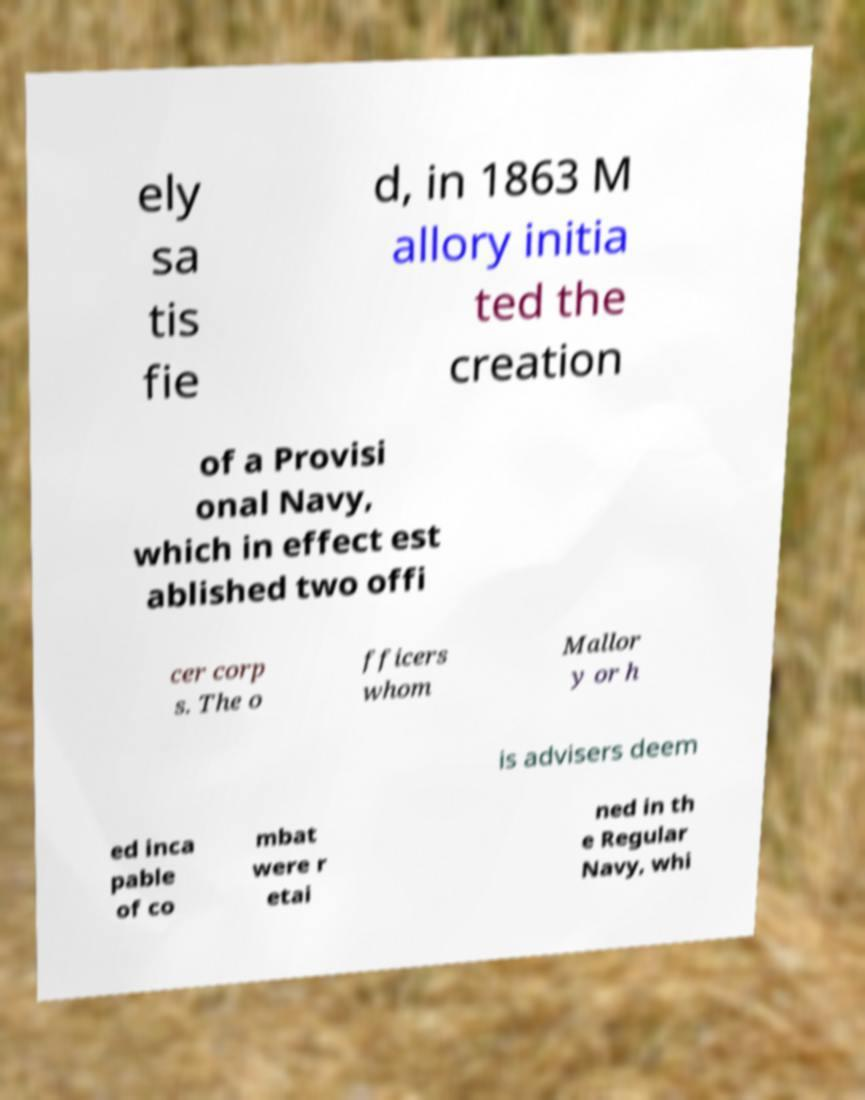Could you assist in decoding the text presented in this image and type it out clearly? ely sa tis fie d, in 1863 M allory initia ted the creation of a Provisi onal Navy, which in effect est ablished two offi cer corp s. The o fficers whom Mallor y or h is advisers deem ed inca pable of co mbat were r etai ned in th e Regular Navy, whi 